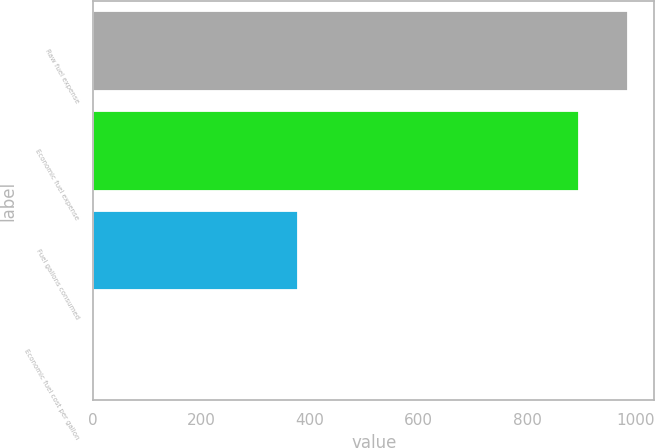<chart> <loc_0><loc_0><loc_500><loc_500><bar_chart><fcel>Raw fuel expense<fcel>Economic fuel expense<fcel>Fuel gallons consumed<fcel>Economic fuel cost per gallon<nl><fcel>985.25<fcel>895.6<fcel>377.3<fcel>2.37<nl></chart> 